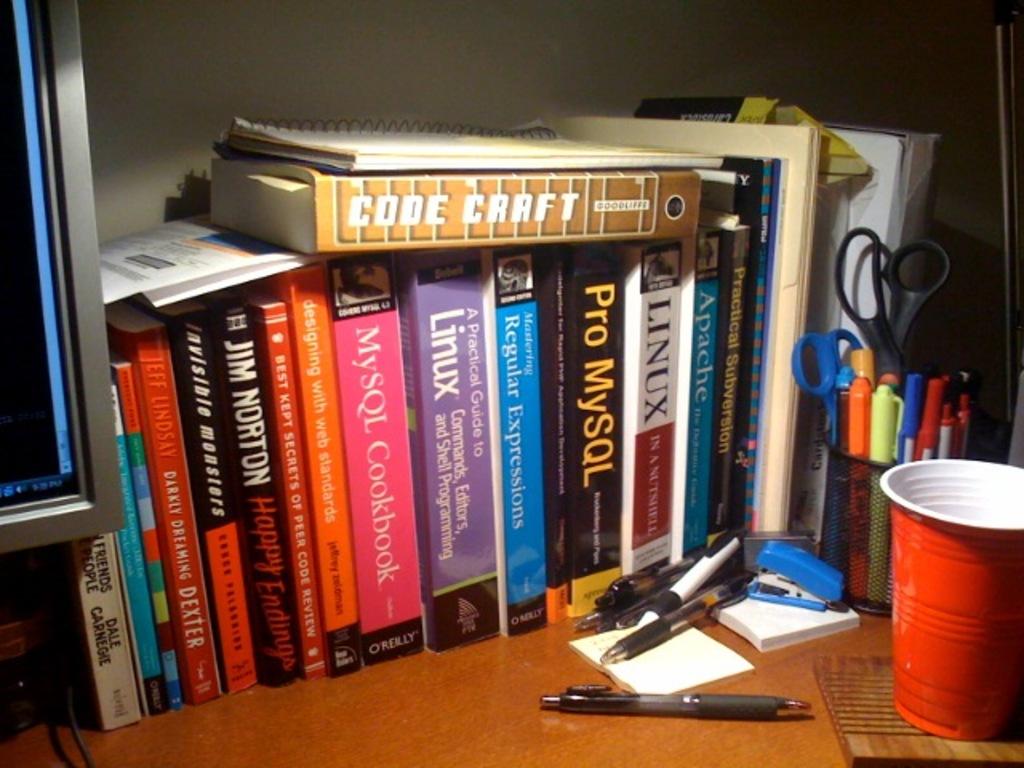What is the title of the black book with yellow font?
Provide a succinct answer. Pro mysql. What is the title of the brown book stacked on top?
Make the answer very short. Code craft. 